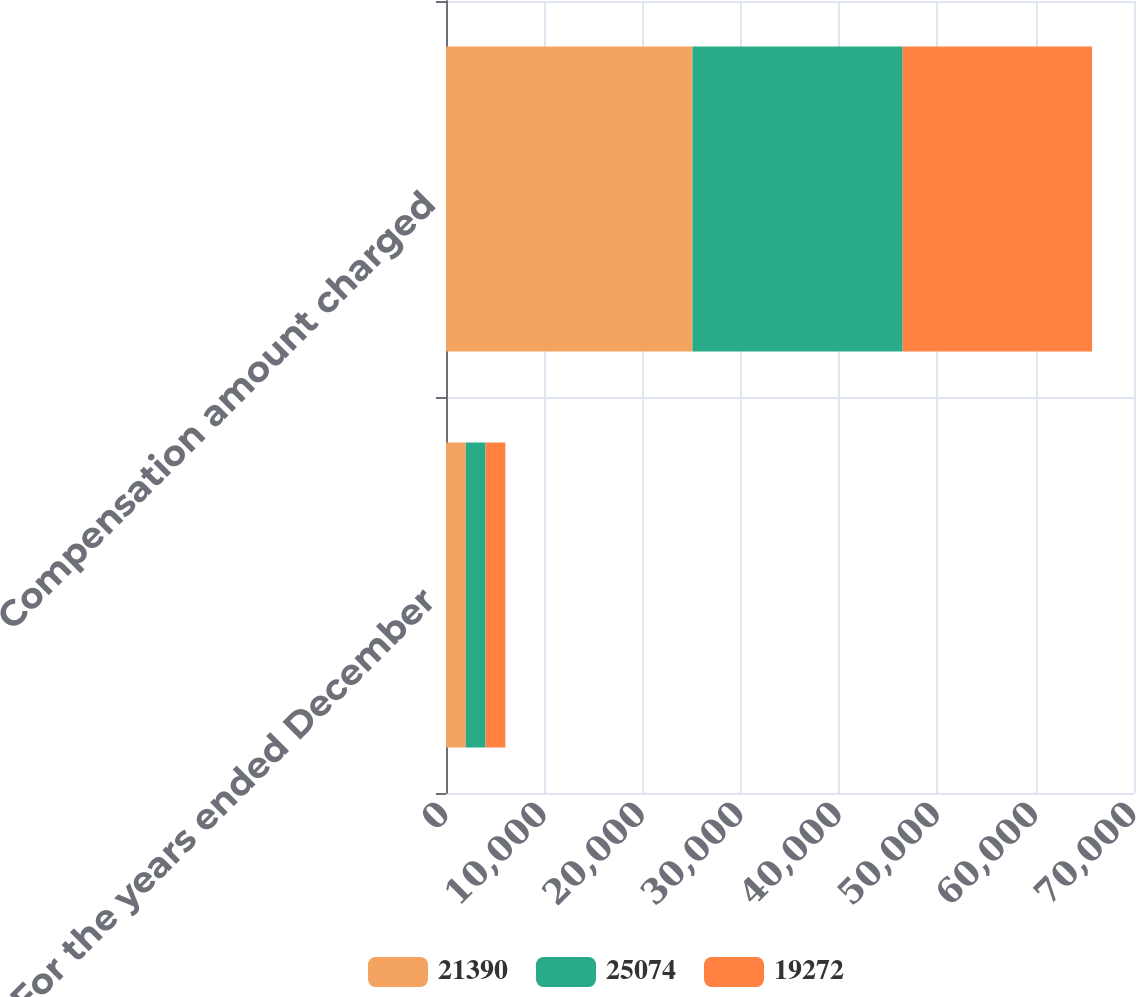Convert chart to OTSL. <chart><loc_0><loc_0><loc_500><loc_500><stacked_bar_chart><ecel><fcel>For the years ended December<fcel>Compensation amount charged<nl><fcel>21390<fcel>2014<fcel>25074<nl><fcel>25074<fcel>2013<fcel>21390<nl><fcel>19272<fcel>2012<fcel>19272<nl></chart> 